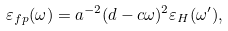Convert formula to latex. <formula><loc_0><loc_0><loc_500><loc_500>\varepsilon _ { f p } ( \omega ) = a ^ { - 2 } ( d - c \omega ) ^ { 2 } \varepsilon _ { H } ( \omega ^ { \prime } ) ,</formula> 